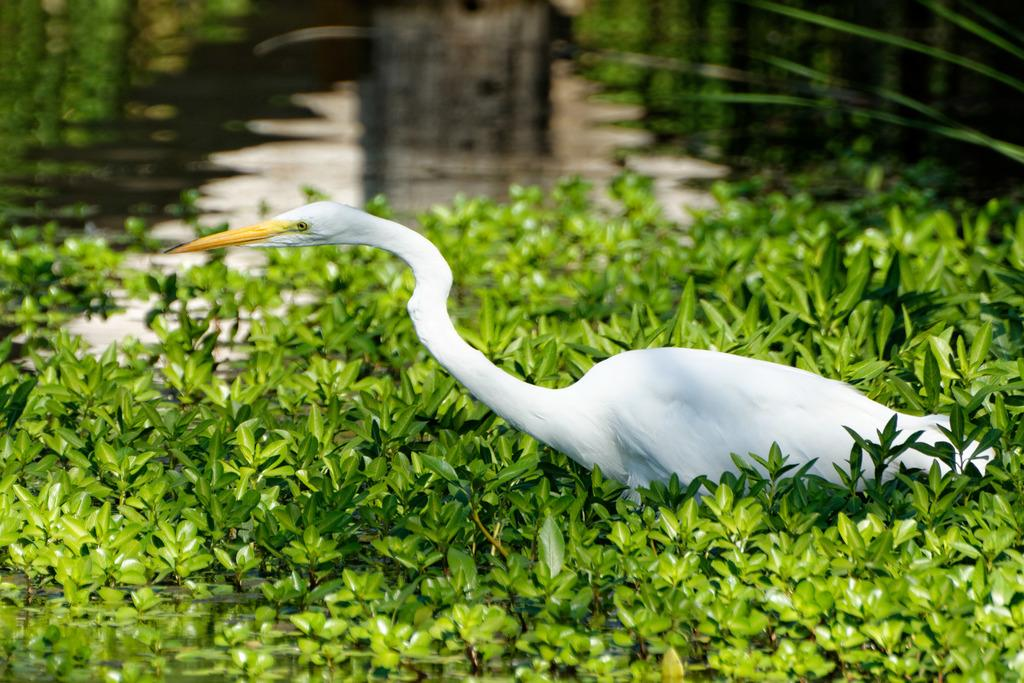What type of animal is in the image? There is a bird in the image. What colors can be seen on the bird? The bird has white and yellow colors. What type of vegetation is present in the image? There are green color leaves in the image. What natural element is visible in the image? There is water visible in the image. How many hands does the bird have in the image? Birds do not have hands; they have wings and feet. In the image, the bird has feet, not hands. 